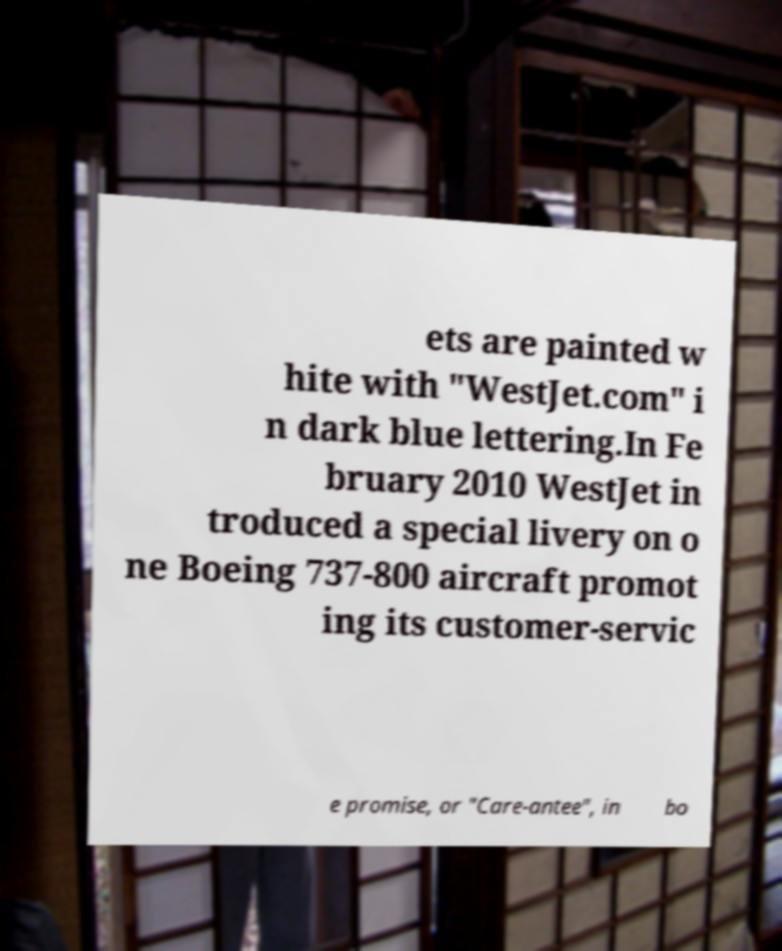For documentation purposes, I need the text within this image transcribed. Could you provide that? ets are painted w hite with "WestJet.com" i n dark blue lettering.In Fe bruary 2010 WestJet in troduced a special livery on o ne Boeing 737-800 aircraft promot ing its customer-servic e promise, or "Care-antee", in bo 